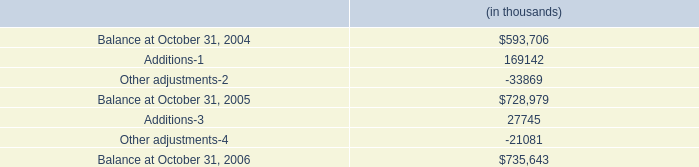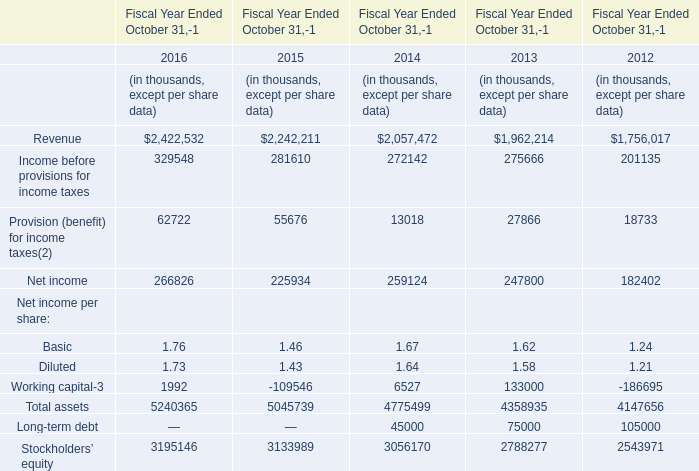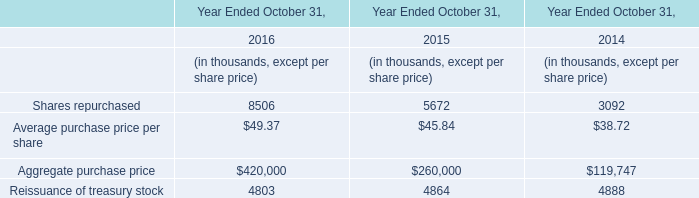What was the average value of the Net income in the years where Revenue is positive? (in thousand) 
Computations: (((((266826 + 225934) + 259124) + 247800) + 182402) / 5)
Answer: 236417.2. 